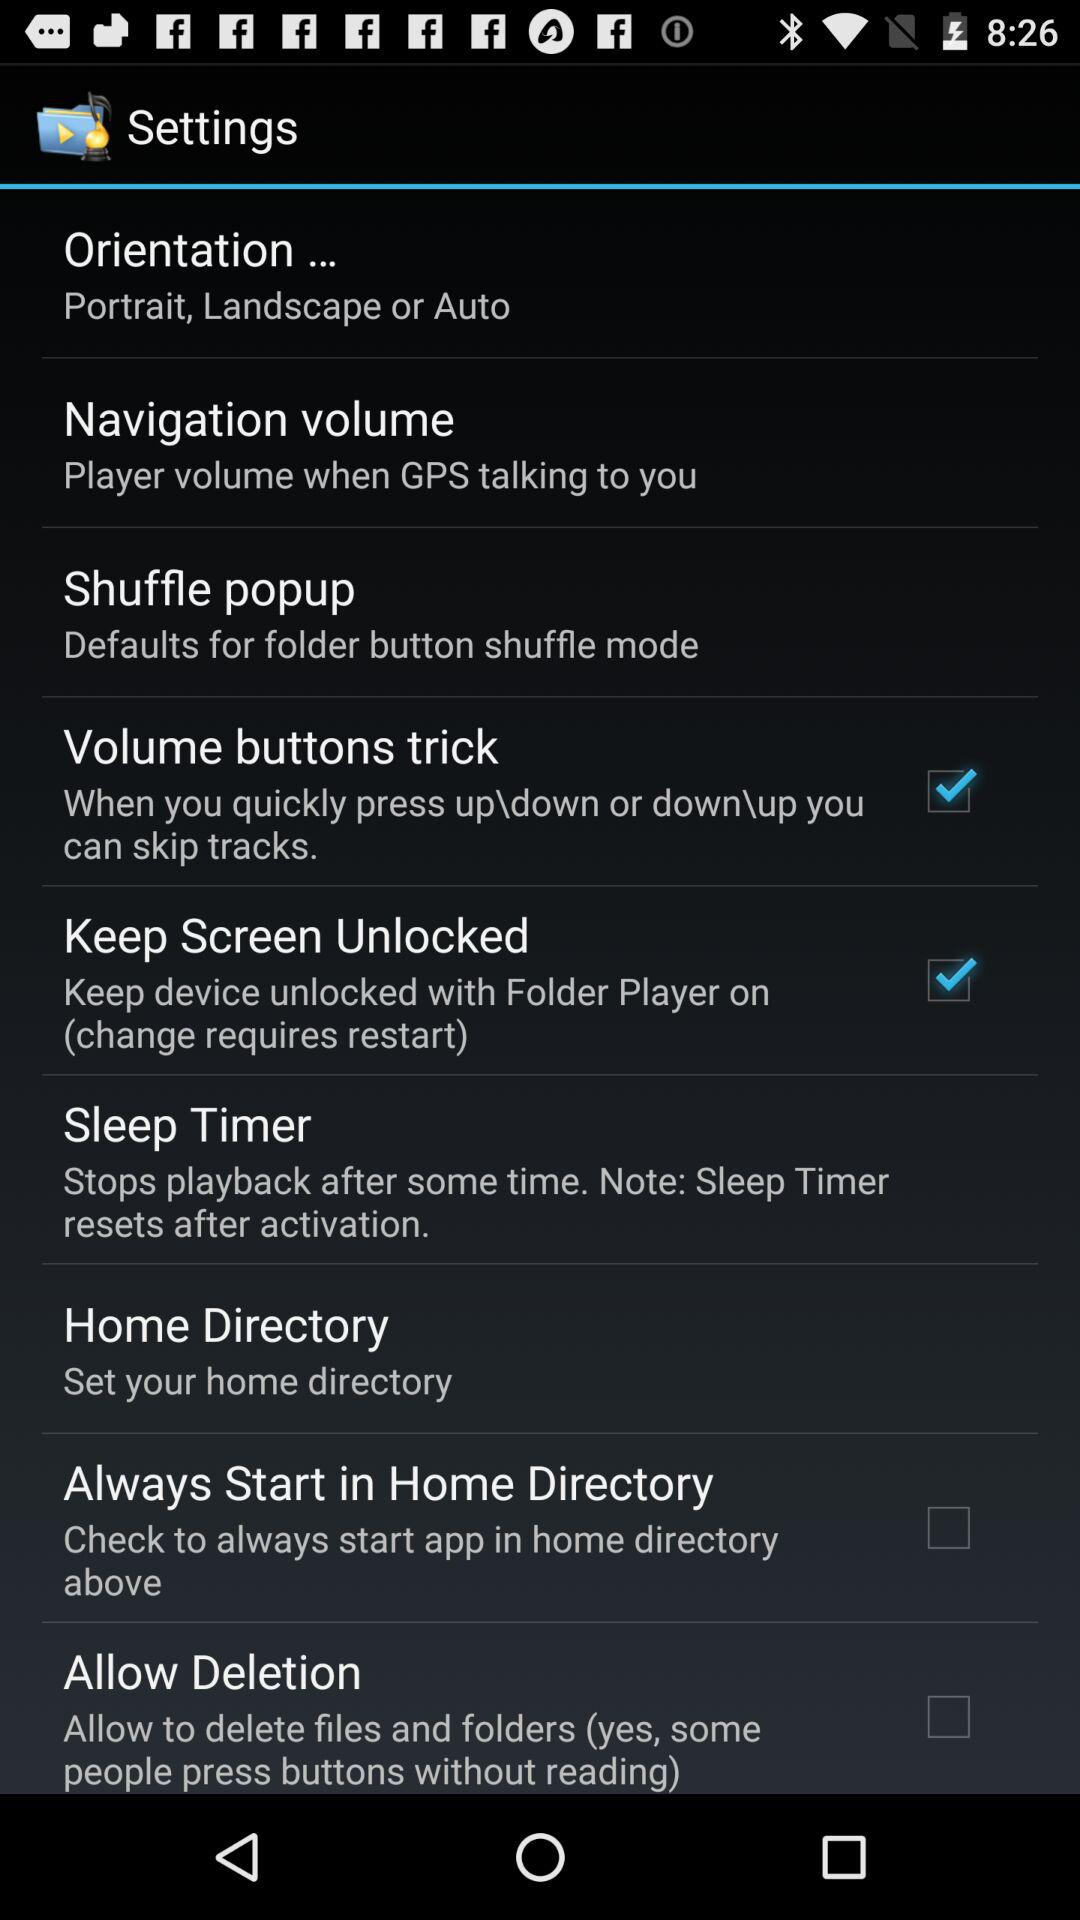Which settings are checked? The checked settings are "Volume buttons trick" and "Keep Screen Unlocked". 